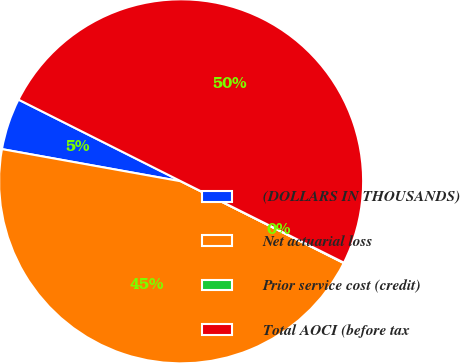Convert chart to OTSL. <chart><loc_0><loc_0><loc_500><loc_500><pie_chart><fcel>(DOLLARS IN THOUSANDS)<fcel>Net actuarial loss<fcel>Prior service cost (credit)<fcel>Total AOCI (before tax<nl><fcel>4.58%<fcel>45.42%<fcel>0.04%<fcel>49.96%<nl></chart> 